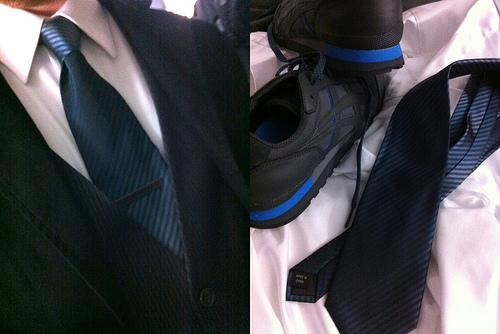Identify the object associated with the shoe on the cloth. A black shoelace is associated with the shoe on the cloth. What is the color and design of the shirt collar? The shirt collar is white and lays down flat. Provide a brief description of the primary accessories in the image. A blue tie with black stripes, a tie clip, a button on a blazer, and a white collar are the primary accessories. What is the main clothing item on the person in the image? The main clothing item is a black dress coat on the man. Where is the blue heel located on the shoe? The blue heel is located at the bottom of the black shoe. Describe the pattern on the tie in the image. The tie has a striped pattern with black and blue colors. What is the color of the tie laying on the cloth? The tie lying on the cloth is black. What does the blue tie under the black jacket have on it? The blue tie has a black tie clip on it. Analyze the sentiment of the image, is it positive, negative, or neutral? The sentiment of the image is neutral. Count the number of black shoes in the image. There are 2 black shoes in the image. 